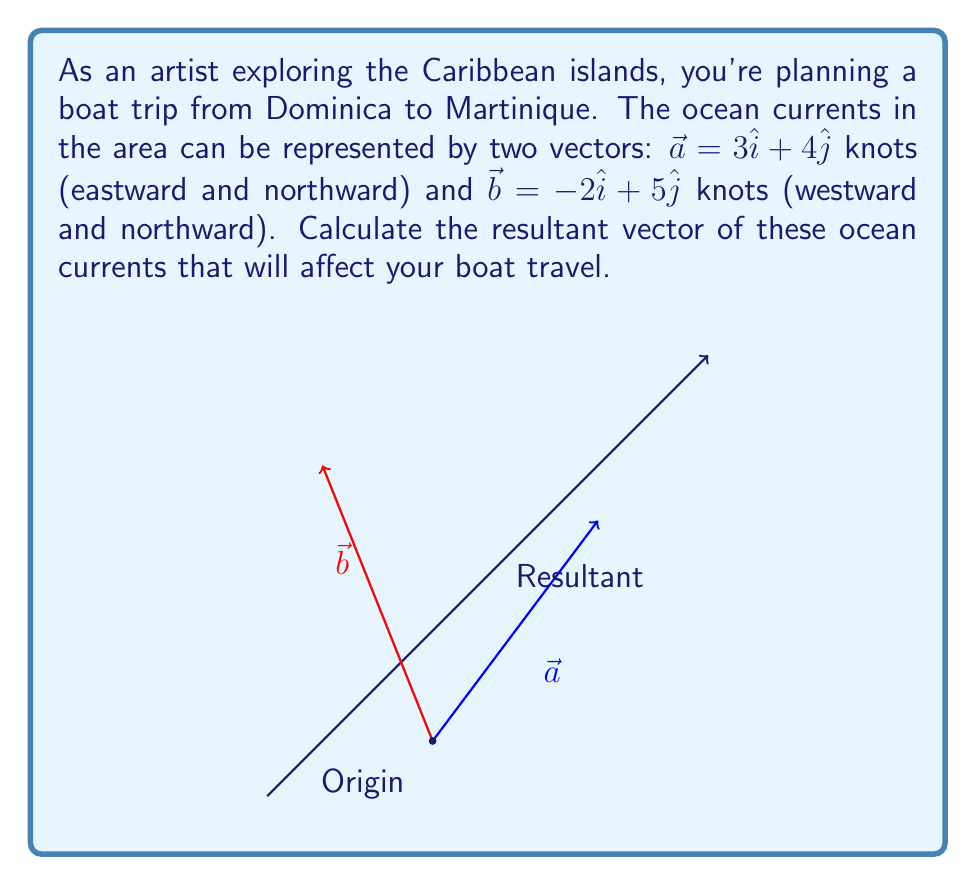Could you help me with this problem? To find the resultant vector, we need to add the two given vectors $\vec{a}$ and $\vec{b}$. Let's approach this step-by-step:

1) First, let's recall the given vectors:
   $\vec{a} = 3\hat{i} + 4\hat{j}$
   $\vec{b} = -2\hat{i} + 5\hat{j}$

2) To add vectors, we add their corresponding components:
   $\vec{r} = \vec{a} + \vec{b} = (3\hat{i} + 4\hat{j}) + (-2\hat{i} + 5\hat{j})$

3) Now, let's combine like terms:
   $\vec{r} = (3-2)\hat{i} + (4+5)\hat{j}$

4) Simplify:
   $\vec{r} = 1\hat{i} + 9\hat{j}$

5) This vector represents the resultant ocean current affecting your boat travel.

6) To interpret this result:
   - The 1 in front of $\hat{i}$ means the current is pushing 1 knot eastward.
   - The 9 in front of $\hat{j}$ means the current is pushing 9 knots northward.

7) We can also calculate the magnitude of this resultant vector using the Pythagorean theorem:
   $|\vec{r}| = \sqrt{1^2 + 9^2} = \sqrt{82} \approx 9.06$ knots

8) The direction of the resultant vector can be found using the arctangent function:
   $\theta = \tan^{-1}(\frac{9}{1}) \approx 83.66°$ from the positive x-axis (east)

Therefore, the resultant ocean current will affect your boat travel with a speed of about 9.06 knots in a direction 83.66° north of east.
Answer: $\vec{r} = 1\hat{i} + 9\hat{j}$ 